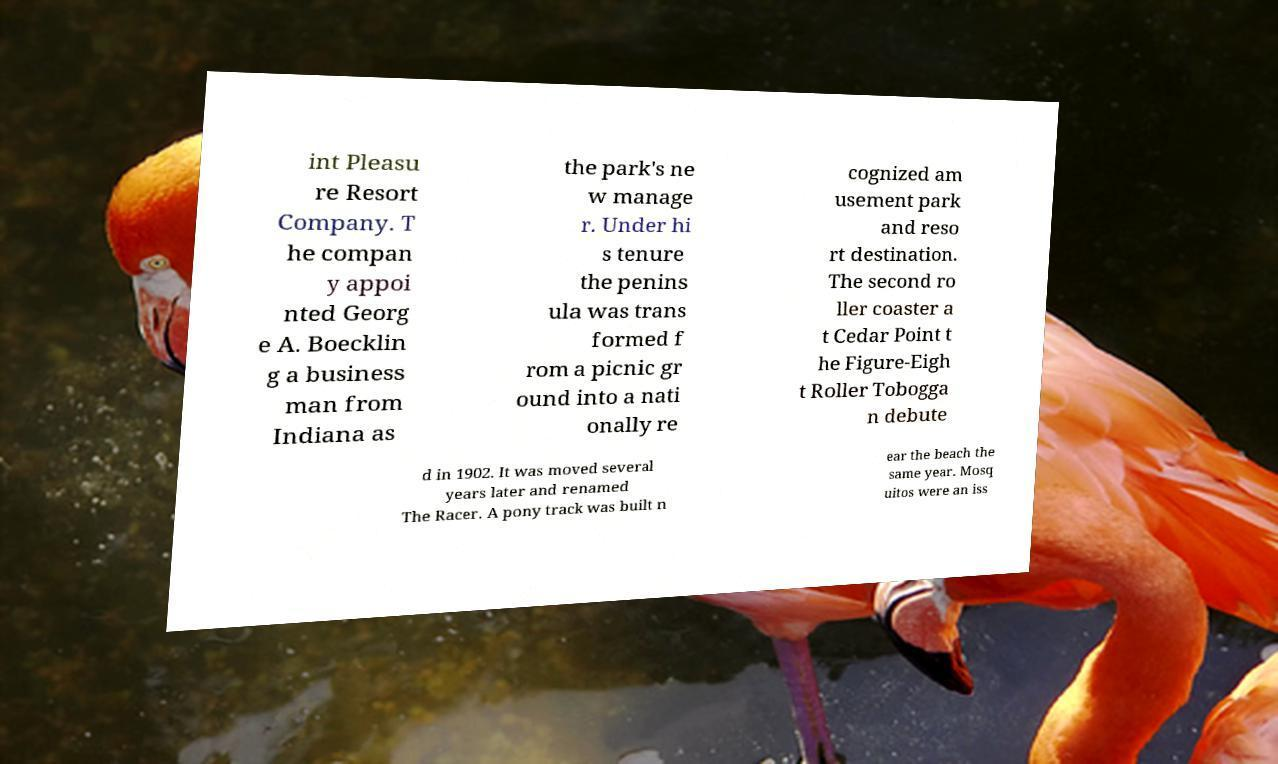Please read and relay the text visible in this image. What does it say? int Pleasu re Resort Company. T he compan y appoi nted Georg e A. Boecklin g a business man from Indiana as the park's ne w manage r. Under hi s tenure the penins ula was trans formed f rom a picnic gr ound into a nati onally re cognized am usement park and reso rt destination. The second ro ller coaster a t Cedar Point t he Figure-Eigh t Roller Tobogga n debute d in 1902. It was moved several years later and renamed The Racer. A pony track was built n ear the beach the same year. Mosq uitos were an iss 